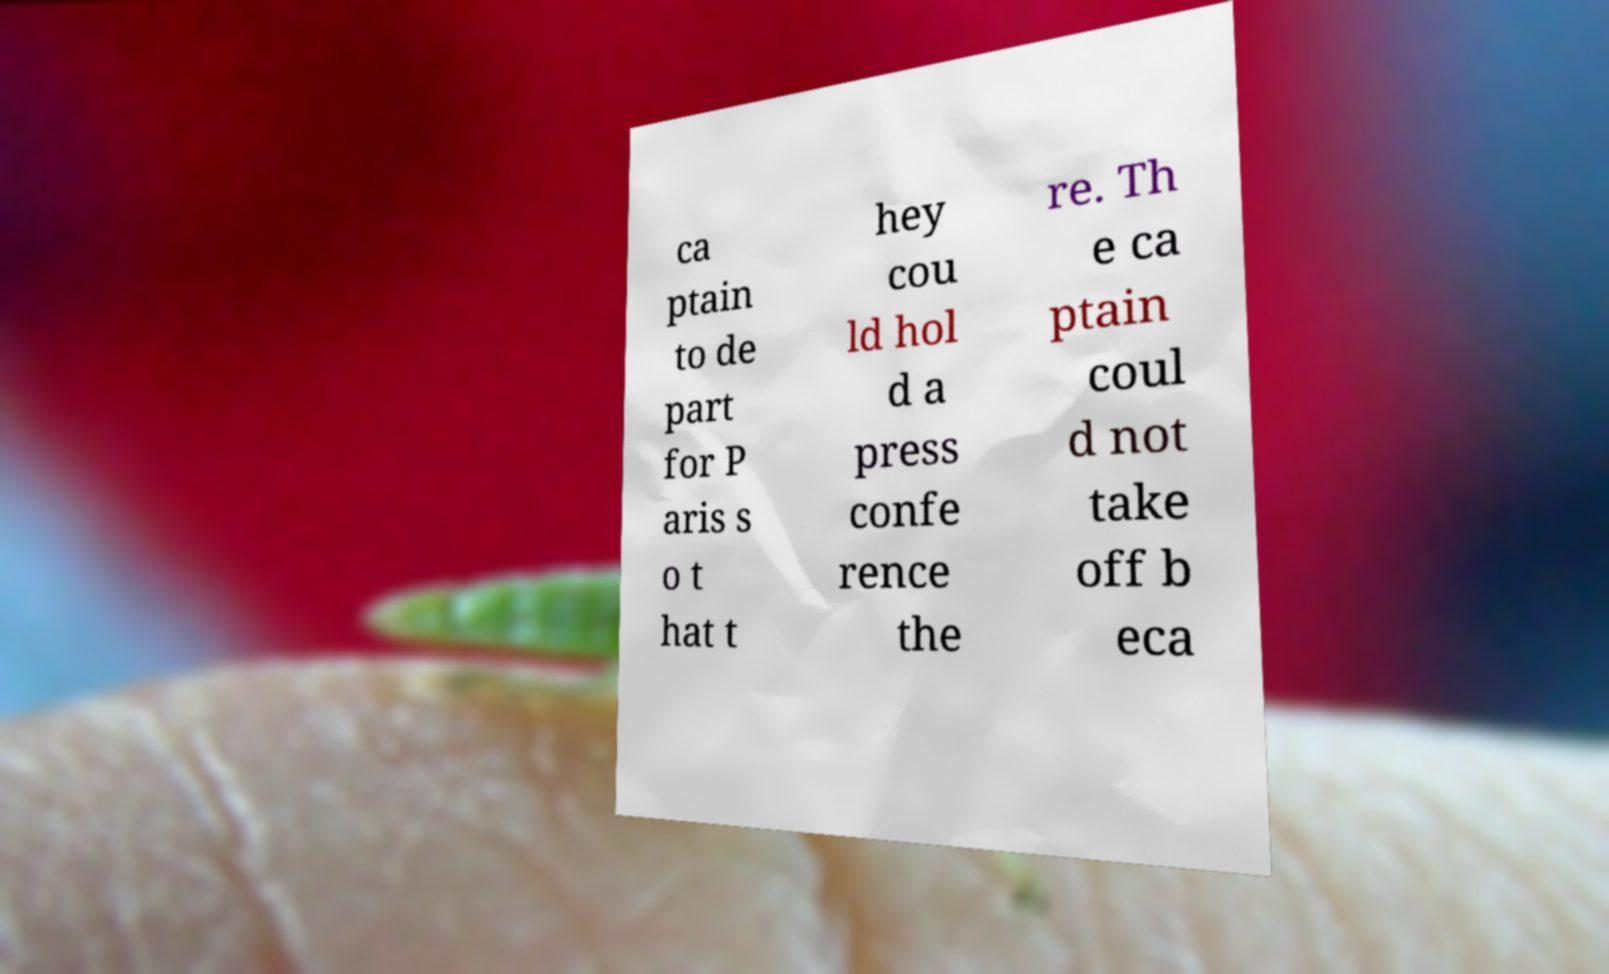Please read and relay the text visible in this image. What does it say? ca ptain to de part for P aris s o t hat t hey cou ld hol d a press confe rence the re. Th e ca ptain coul d not take off b eca 